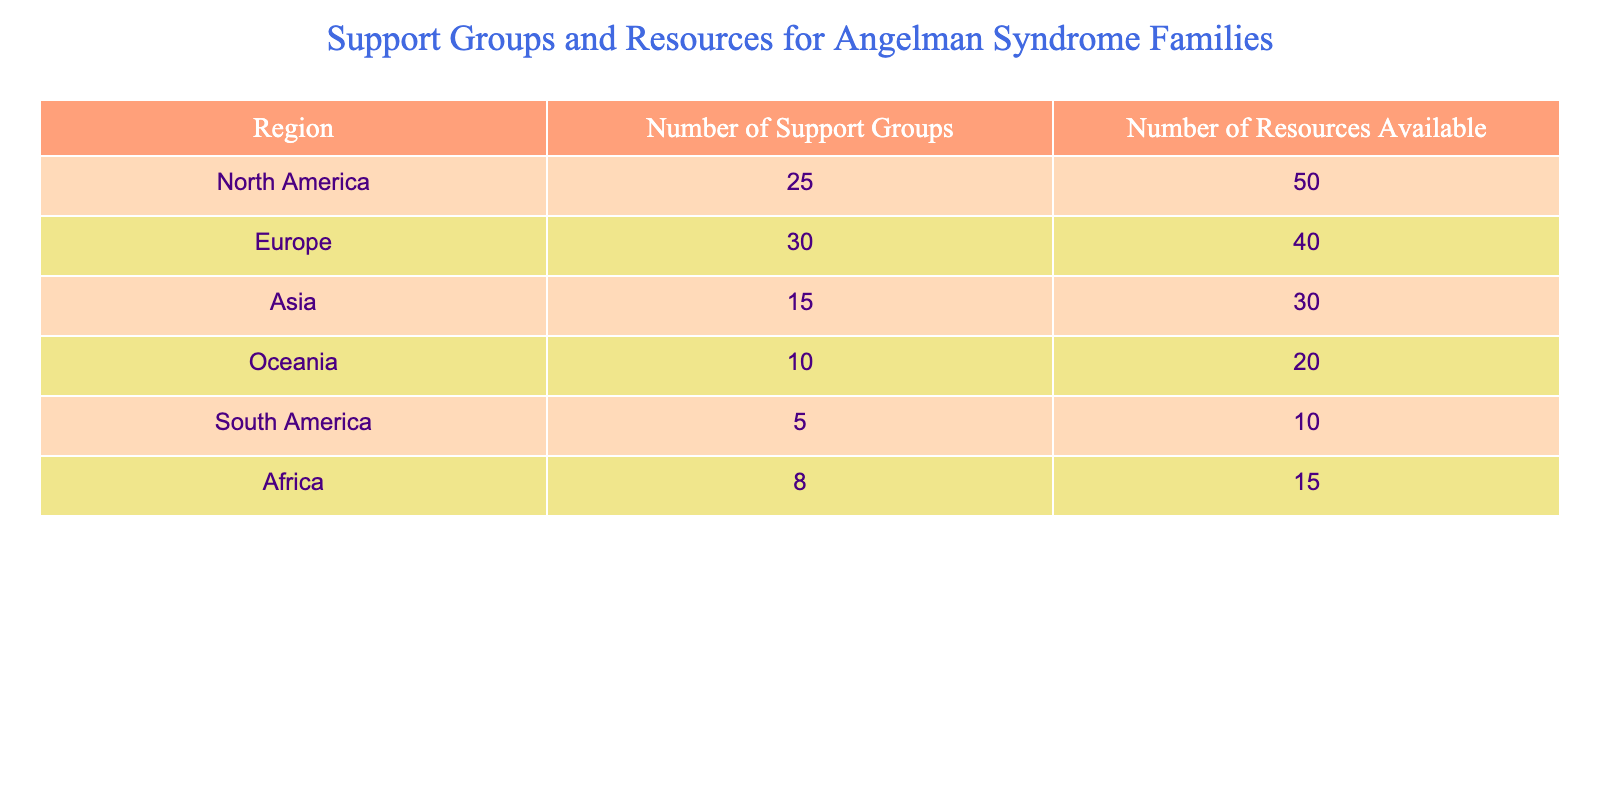What region has the highest number of support groups? By reviewing the "Number of Support Groups" column in the table, North America has 25 support groups, which is higher than any other region listed: Europe (30), Asia (15), Oceania (10), South America (5), and Africa (8). Therefore, the region with the highest number of support groups is Europe.
Answer: Europe How many total resources are available across all regions? To find the total resources available, we sum the values from the "Number of Resources Available" column: 50 (North America) + 40 (Europe) + 30 (Asia) + 20 (Oceania) + 10 (South America) + 15 (Africa) = 165.
Answer: 165 Is the number of support groups in Asia greater than the number of support groups in South America? Asia has 15 support groups and South America has 5 support groups. Since 15 is greater than 5, the statement is true.
Answer: Yes What is the average number of support groups per region? There are 6 regions listed in the table. To find the average number of support groups, we sum the values: 25 + 30 + 15 + 10 + 5 + 8 = 93. Then, we divide by the number of regions: 93 / 6 = 15.5.
Answer: 15.5 Which region has the least resources available? Upon inspecting the "Number of Resources Available" column, we see South America with 10 resources, which is fewer than any other region: North America (50), Europe (40), Asia (30), Oceania (20), and Africa (15).
Answer: South America What is the difference in the number of resources available between North America and Africa? North America has 50 resources and Africa has 15 resources. To find the difference, we subtract: 50 - 15 = 35.
Answer: 35 Is there more than one region with 10 or more resources available? By reviewing the "Number of Resources Available" column, we count the regions with at least 10 resources. North America (50), Europe (40), Asia (30), Oceania (20), and Africa (15) all qualify, totaling 5 regions. Thus, the statement is true.
Answer: Yes What percentage of the total resources available are in Europe? First, we need to find the total number of resources which is 165. Europe has 40 resources, so to find the percentage: (40 / 165) * 100 ≈ 24.24%.
Answer: 24.24% What is the ratio of support groups in North America to Asia? North America has 25 support groups while Asia has 15. The ratio can be expressed as 25:15, which simplifies to 5:3 by dividing both numbers by 5.
Answer: 5:3 